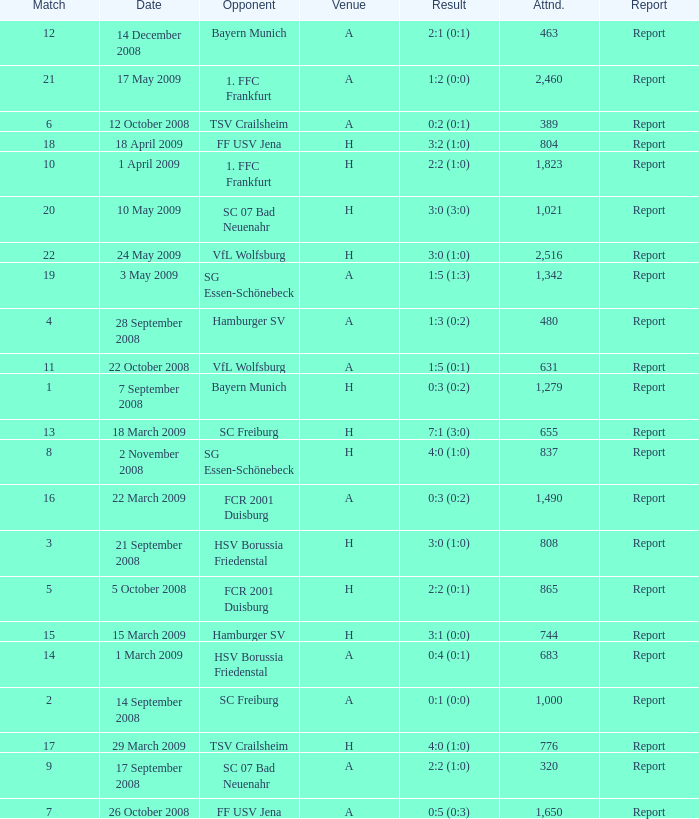Which match had more than 1,490 people in attendance to watch FCR 2001 Duisburg have a result of 0:3 (0:2)? None. 